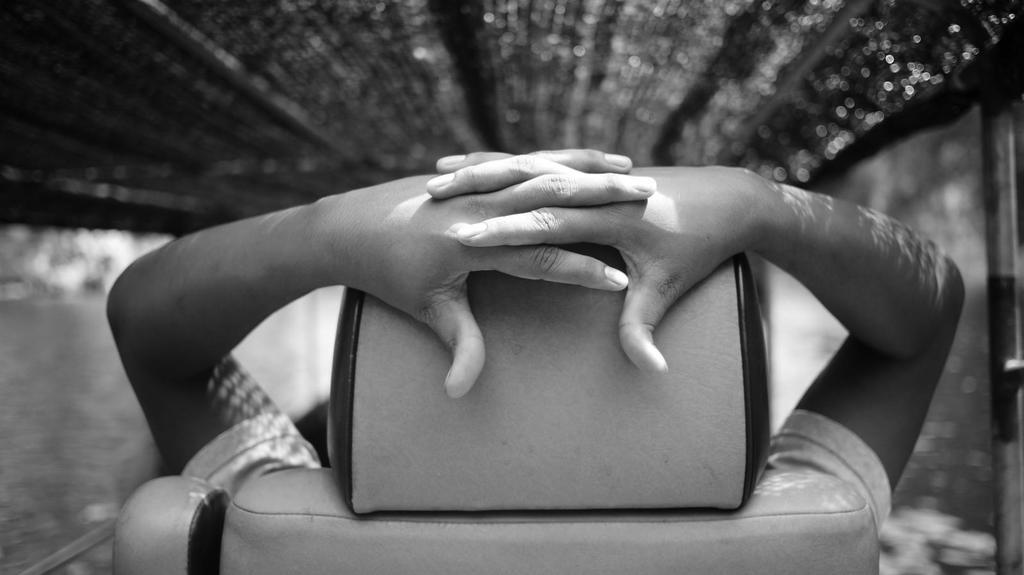Who or what is the main subject in the image? There is a person in the image. What is the person doing in the image? The person appears to be sitting. Where is the person sitting in the image? The person is in a boat. What can be seen in the background of the image? The background is blurry. What type of belief system does the governor in the image follow? There is no governor present in the image, and therefore no information about their belief system can be determined. 